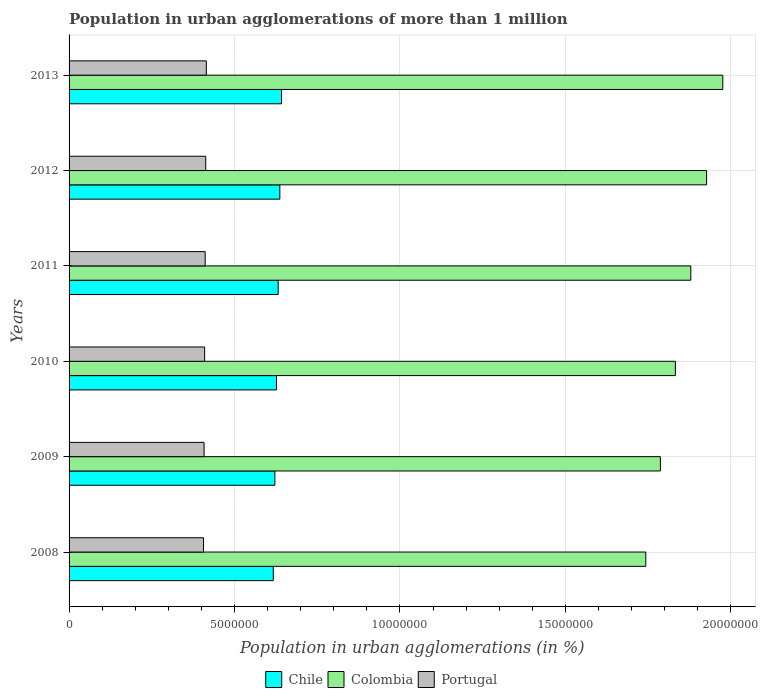How many different coloured bars are there?
Make the answer very short. 3. How many groups of bars are there?
Provide a short and direct response. 6. Are the number of bars on each tick of the Y-axis equal?
Give a very brief answer. Yes. What is the label of the 1st group of bars from the top?
Provide a succinct answer. 2013. In how many cases, is the number of bars for a given year not equal to the number of legend labels?
Make the answer very short. 0. What is the population in urban agglomerations in Colombia in 2012?
Ensure brevity in your answer.  1.93e+07. Across all years, what is the maximum population in urban agglomerations in Chile?
Your answer should be very brief. 6.42e+06. Across all years, what is the minimum population in urban agglomerations in Portugal?
Your answer should be very brief. 4.06e+06. What is the total population in urban agglomerations in Chile in the graph?
Your answer should be compact. 3.78e+07. What is the difference between the population in urban agglomerations in Colombia in 2010 and that in 2011?
Keep it short and to the point. -4.65e+05. What is the difference between the population in urban agglomerations in Colombia in 2010 and the population in urban agglomerations in Chile in 2012?
Your answer should be compact. 1.20e+07. What is the average population in urban agglomerations in Portugal per year?
Keep it short and to the point. 4.11e+06. In the year 2008, what is the difference between the population in urban agglomerations in Colombia and population in urban agglomerations in Portugal?
Your response must be concise. 1.34e+07. In how many years, is the population in urban agglomerations in Portugal greater than 19000000 %?
Provide a short and direct response. 0. What is the ratio of the population in urban agglomerations in Portugal in 2008 to that in 2009?
Make the answer very short. 1. Is the difference between the population in urban agglomerations in Colombia in 2010 and 2013 greater than the difference between the population in urban agglomerations in Portugal in 2010 and 2013?
Give a very brief answer. No. What is the difference between the highest and the second highest population in urban agglomerations in Colombia?
Your answer should be compact. 4.90e+05. What is the difference between the highest and the lowest population in urban agglomerations in Chile?
Offer a terse response. 2.50e+05. In how many years, is the population in urban agglomerations in Colombia greater than the average population in urban agglomerations in Colombia taken over all years?
Give a very brief answer. 3. What does the 3rd bar from the top in 2013 represents?
Provide a short and direct response. Chile. How many bars are there?
Offer a very short reply. 18. Does the graph contain any zero values?
Your answer should be compact. No. Does the graph contain grids?
Provide a short and direct response. Yes. Where does the legend appear in the graph?
Offer a terse response. Bottom center. How many legend labels are there?
Provide a short and direct response. 3. What is the title of the graph?
Provide a succinct answer. Population in urban agglomerations of more than 1 million. What is the label or title of the X-axis?
Offer a very short reply. Population in urban agglomerations (in %). What is the Population in urban agglomerations (in %) of Chile in 2008?
Offer a very short reply. 6.17e+06. What is the Population in urban agglomerations (in %) in Colombia in 2008?
Keep it short and to the point. 1.74e+07. What is the Population in urban agglomerations (in %) in Portugal in 2008?
Ensure brevity in your answer.  4.06e+06. What is the Population in urban agglomerations (in %) in Chile in 2009?
Provide a short and direct response. 6.22e+06. What is the Population in urban agglomerations (in %) of Colombia in 2009?
Ensure brevity in your answer.  1.79e+07. What is the Population in urban agglomerations (in %) of Portugal in 2009?
Ensure brevity in your answer.  4.08e+06. What is the Population in urban agglomerations (in %) in Chile in 2010?
Provide a short and direct response. 6.27e+06. What is the Population in urban agglomerations (in %) of Colombia in 2010?
Your response must be concise. 1.83e+07. What is the Population in urban agglomerations (in %) of Portugal in 2010?
Give a very brief answer. 4.10e+06. What is the Population in urban agglomerations (in %) of Chile in 2011?
Your answer should be compact. 6.32e+06. What is the Population in urban agglomerations (in %) in Colombia in 2011?
Your answer should be very brief. 1.88e+07. What is the Population in urban agglomerations (in %) of Portugal in 2011?
Provide a short and direct response. 4.11e+06. What is the Population in urban agglomerations (in %) of Chile in 2012?
Make the answer very short. 6.37e+06. What is the Population in urban agglomerations (in %) in Colombia in 2012?
Your answer should be very brief. 1.93e+07. What is the Population in urban agglomerations (in %) in Portugal in 2012?
Ensure brevity in your answer.  4.13e+06. What is the Population in urban agglomerations (in %) of Chile in 2013?
Your answer should be compact. 6.42e+06. What is the Population in urban agglomerations (in %) of Colombia in 2013?
Your answer should be very brief. 1.98e+07. What is the Population in urban agglomerations (in %) in Portugal in 2013?
Ensure brevity in your answer.  4.15e+06. Across all years, what is the maximum Population in urban agglomerations (in %) in Chile?
Your answer should be compact. 6.42e+06. Across all years, what is the maximum Population in urban agglomerations (in %) of Colombia?
Keep it short and to the point. 1.98e+07. Across all years, what is the maximum Population in urban agglomerations (in %) of Portugal?
Make the answer very short. 4.15e+06. Across all years, what is the minimum Population in urban agglomerations (in %) in Chile?
Provide a short and direct response. 6.17e+06. Across all years, what is the minimum Population in urban agglomerations (in %) in Colombia?
Your response must be concise. 1.74e+07. Across all years, what is the minimum Population in urban agglomerations (in %) in Portugal?
Make the answer very short. 4.06e+06. What is the total Population in urban agglomerations (in %) in Chile in the graph?
Keep it short and to the point. 3.78e+07. What is the total Population in urban agglomerations (in %) in Colombia in the graph?
Give a very brief answer. 1.11e+08. What is the total Population in urban agglomerations (in %) in Portugal in the graph?
Your answer should be very brief. 2.46e+07. What is the difference between the Population in urban agglomerations (in %) of Chile in 2008 and that in 2009?
Your answer should be compact. -4.91e+04. What is the difference between the Population in urban agglomerations (in %) in Colombia in 2008 and that in 2009?
Provide a short and direct response. -4.41e+05. What is the difference between the Population in urban agglomerations (in %) of Portugal in 2008 and that in 2009?
Provide a short and direct response. -1.67e+04. What is the difference between the Population in urban agglomerations (in %) of Chile in 2008 and that in 2010?
Offer a terse response. -9.87e+04. What is the difference between the Population in urban agglomerations (in %) in Colombia in 2008 and that in 2010?
Make the answer very short. -8.95e+05. What is the difference between the Population in urban agglomerations (in %) of Portugal in 2008 and that in 2010?
Offer a terse response. -3.35e+04. What is the difference between the Population in urban agglomerations (in %) of Chile in 2008 and that in 2011?
Give a very brief answer. -1.49e+05. What is the difference between the Population in urban agglomerations (in %) in Colombia in 2008 and that in 2011?
Keep it short and to the point. -1.36e+06. What is the difference between the Population in urban agglomerations (in %) of Portugal in 2008 and that in 2011?
Give a very brief answer. -5.04e+04. What is the difference between the Population in urban agglomerations (in %) in Chile in 2008 and that in 2012?
Give a very brief answer. -1.99e+05. What is the difference between the Population in urban agglomerations (in %) in Colombia in 2008 and that in 2012?
Keep it short and to the point. -1.84e+06. What is the difference between the Population in urban agglomerations (in %) of Portugal in 2008 and that in 2012?
Your answer should be very brief. -6.74e+04. What is the difference between the Population in urban agglomerations (in %) of Chile in 2008 and that in 2013?
Offer a terse response. -2.50e+05. What is the difference between the Population in urban agglomerations (in %) in Colombia in 2008 and that in 2013?
Offer a terse response. -2.33e+06. What is the difference between the Population in urban agglomerations (in %) in Portugal in 2008 and that in 2013?
Give a very brief answer. -8.44e+04. What is the difference between the Population in urban agglomerations (in %) of Chile in 2009 and that in 2010?
Provide a short and direct response. -4.96e+04. What is the difference between the Population in urban agglomerations (in %) in Colombia in 2009 and that in 2010?
Ensure brevity in your answer.  -4.53e+05. What is the difference between the Population in urban agglomerations (in %) of Portugal in 2009 and that in 2010?
Offer a terse response. -1.68e+04. What is the difference between the Population in urban agglomerations (in %) in Chile in 2009 and that in 2011?
Your answer should be compact. -9.95e+04. What is the difference between the Population in urban agglomerations (in %) in Colombia in 2009 and that in 2011?
Your answer should be very brief. -9.19e+05. What is the difference between the Population in urban agglomerations (in %) in Portugal in 2009 and that in 2011?
Make the answer very short. -3.37e+04. What is the difference between the Population in urban agglomerations (in %) in Chile in 2009 and that in 2012?
Your answer should be very brief. -1.50e+05. What is the difference between the Population in urban agglomerations (in %) in Colombia in 2009 and that in 2012?
Give a very brief answer. -1.40e+06. What is the difference between the Population in urban agglomerations (in %) of Portugal in 2009 and that in 2012?
Offer a very short reply. -5.07e+04. What is the difference between the Population in urban agglomerations (in %) of Chile in 2009 and that in 2013?
Your response must be concise. -2.01e+05. What is the difference between the Population in urban agglomerations (in %) of Colombia in 2009 and that in 2013?
Ensure brevity in your answer.  -1.89e+06. What is the difference between the Population in urban agglomerations (in %) in Portugal in 2009 and that in 2013?
Offer a very short reply. -6.77e+04. What is the difference between the Population in urban agglomerations (in %) in Chile in 2010 and that in 2011?
Your response must be concise. -5.00e+04. What is the difference between the Population in urban agglomerations (in %) in Colombia in 2010 and that in 2011?
Ensure brevity in your answer.  -4.65e+05. What is the difference between the Population in urban agglomerations (in %) in Portugal in 2010 and that in 2011?
Provide a succinct answer. -1.69e+04. What is the difference between the Population in urban agglomerations (in %) of Chile in 2010 and that in 2012?
Your answer should be very brief. -1.00e+05. What is the difference between the Population in urban agglomerations (in %) of Colombia in 2010 and that in 2012?
Offer a terse response. -9.43e+05. What is the difference between the Population in urban agglomerations (in %) of Portugal in 2010 and that in 2012?
Keep it short and to the point. -3.39e+04. What is the difference between the Population in urban agglomerations (in %) in Chile in 2010 and that in 2013?
Keep it short and to the point. -1.51e+05. What is the difference between the Population in urban agglomerations (in %) of Colombia in 2010 and that in 2013?
Give a very brief answer. -1.43e+06. What is the difference between the Population in urban agglomerations (in %) in Portugal in 2010 and that in 2013?
Provide a short and direct response. -5.09e+04. What is the difference between the Population in urban agglomerations (in %) of Chile in 2011 and that in 2012?
Your answer should be compact. -5.04e+04. What is the difference between the Population in urban agglomerations (in %) in Colombia in 2011 and that in 2012?
Provide a short and direct response. -4.77e+05. What is the difference between the Population in urban agglomerations (in %) of Portugal in 2011 and that in 2012?
Provide a short and direct response. -1.70e+04. What is the difference between the Population in urban agglomerations (in %) of Chile in 2011 and that in 2013?
Offer a very short reply. -1.01e+05. What is the difference between the Population in urban agglomerations (in %) of Colombia in 2011 and that in 2013?
Give a very brief answer. -9.67e+05. What is the difference between the Population in urban agglomerations (in %) of Portugal in 2011 and that in 2013?
Give a very brief answer. -3.40e+04. What is the difference between the Population in urban agglomerations (in %) of Chile in 2012 and that in 2013?
Make the answer very short. -5.08e+04. What is the difference between the Population in urban agglomerations (in %) of Colombia in 2012 and that in 2013?
Make the answer very short. -4.90e+05. What is the difference between the Population in urban agglomerations (in %) of Portugal in 2012 and that in 2013?
Provide a short and direct response. -1.70e+04. What is the difference between the Population in urban agglomerations (in %) of Chile in 2008 and the Population in urban agglomerations (in %) of Colombia in 2009?
Ensure brevity in your answer.  -1.17e+07. What is the difference between the Population in urban agglomerations (in %) of Chile in 2008 and the Population in urban agglomerations (in %) of Portugal in 2009?
Your response must be concise. 2.09e+06. What is the difference between the Population in urban agglomerations (in %) in Colombia in 2008 and the Population in urban agglomerations (in %) in Portugal in 2009?
Your response must be concise. 1.33e+07. What is the difference between the Population in urban agglomerations (in %) of Chile in 2008 and the Population in urban agglomerations (in %) of Colombia in 2010?
Provide a succinct answer. -1.22e+07. What is the difference between the Population in urban agglomerations (in %) in Chile in 2008 and the Population in urban agglomerations (in %) in Portugal in 2010?
Your response must be concise. 2.07e+06. What is the difference between the Population in urban agglomerations (in %) of Colombia in 2008 and the Population in urban agglomerations (in %) of Portugal in 2010?
Make the answer very short. 1.33e+07. What is the difference between the Population in urban agglomerations (in %) of Chile in 2008 and the Population in urban agglomerations (in %) of Colombia in 2011?
Make the answer very short. -1.26e+07. What is the difference between the Population in urban agglomerations (in %) of Chile in 2008 and the Population in urban agglomerations (in %) of Portugal in 2011?
Give a very brief answer. 2.06e+06. What is the difference between the Population in urban agglomerations (in %) in Colombia in 2008 and the Population in urban agglomerations (in %) in Portugal in 2011?
Offer a very short reply. 1.33e+07. What is the difference between the Population in urban agglomerations (in %) of Chile in 2008 and the Population in urban agglomerations (in %) of Colombia in 2012?
Keep it short and to the point. -1.31e+07. What is the difference between the Population in urban agglomerations (in %) of Chile in 2008 and the Population in urban agglomerations (in %) of Portugal in 2012?
Offer a terse response. 2.04e+06. What is the difference between the Population in urban agglomerations (in %) of Colombia in 2008 and the Population in urban agglomerations (in %) of Portugal in 2012?
Offer a very short reply. 1.33e+07. What is the difference between the Population in urban agglomerations (in %) of Chile in 2008 and the Population in urban agglomerations (in %) of Colombia in 2013?
Your answer should be very brief. -1.36e+07. What is the difference between the Population in urban agglomerations (in %) of Chile in 2008 and the Population in urban agglomerations (in %) of Portugal in 2013?
Your answer should be very brief. 2.02e+06. What is the difference between the Population in urban agglomerations (in %) of Colombia in 2008 and the Population in urban agglomerations (in %) of Portugal in 2013?
Keep it short and to the point. 1.33e+07. What is the difference between the Population in urban agglomerations (in %) of Chile in 2009 and the Population in urban agglomerations (in %) of Colombia in 2010?
Provide a succinct answer. -1.21e+07. What is the difference between the Population in urban agglomerations (in %) of Chile in 2009 and the Population in urban agglomerations (in %) of Portugal in 2010?
Keep it short and to the point. 2.12e+06. What is the difference between the Population in urban agglomerations (in %) of Colombia in 2009 and the Population in urban agglomerations (in %) of Portugal in 2010?
Offer a terse response. 1.38e+07. What is the difference between the Population in urban agglomerations (in %) in Chile in 2009 and the Population in urban agglomerations (in %) in Colombia in 2011?
Provide a succinct answer. -1.26e+07. What is the difference between the Population in urban agglomerations (in %) of Chile in 2009 and the Population in urban agglomerations (in %) of Portugal in 2011?
Your response must be concise. 2.11e+06. What is the difference between the Population in urban agglomerations (in %) of Colombia in 2009 and the Population in urban agglomerations (in %) of Portugal in 2011?
Provide a short and direct response. 1.38e+07. What is the difference between the Population in urban agglomerations (in %) of Chile in 2009 and the Population in urban agglomerations (in %) of Colombia in 2012?
Offer a very short reply. -1.30e+07. What is the difference between the Population in urban agglomerations (in %) of Chile in 2009 and the Population in urban agglomerations (in %) of Portugal in 2012?
Offer a terse response. 2.09e+06. What is the difference between the Population in urban agglomerations (in %) of Colombia in 2009 and the Population in urban agglomerations (in %) of Portugal in 2012?
Your response must be concise. 1.37e+07. What is the difference between the Population in urban agglomerations (in %) of Chile in 2009 and the Population in urban agglomerations (in %) of Colombia in 2013?
Provide a succinct answer. -1.35e+07. What is the difference between the Population in urban agglomerations (in %) in Chile in 2009 and the Population in urban agglomerations (in %) in Portugal in 2013?
Provide a succinct answer. 2.07e+06. What is the difference between the Population in urban agglomerations (in %) in Colombia in 2009 and the Population in urban agglomerations (in %) in Portugal in 2013?
Your answer should be very brief. 1.37e+07. What is the difference between the Population in urban agglomerations (in %) in Chile in 2010 and the Population in urban agglomerations (in %) in Colombia in 2011?
Keep it short and to the point. -1.25e+07. What is the difference between the Population in urban agglomerations (in %) in Chile in 2010 and the Population in urban agglomerations (in %) in Portugal in 2011?
Your answer should be compact. 2.16e+06. What is the difference between the Population in urban agglomerations (in %) of Colombia in 2010 and the Population in urban agglomerations (in %) of Portugal in 2011?
Offer a terse response. 1.42e+07. What is the difference between the Population in urban agglomerations (in %) of Chile in 2010 and the Population in urban agglomerations (in %) of Colombia in 2012?
Your answer should be compact. -1.30e+07. What is the difference between the Population in urban agglomerations (in %) in Chile in 2010 and the Population in urban agglomerations (in %) in Portugal in 2012?
Provide a short and direct response. 2.14e+06. What is the difference between the Population in urban agglomerations (in %) in Colombia in 2010 and the Population in urban agglomerations (in %) in Portugal in 2012?
Give a very brief answer. 1.42e+07. What is the difference between the Population in urban agglomerations (in %) of Chile in 2010 and the Population in urban agglomerations (in %) of Colombia in 2013?
Your answer should be compact. -1.35e+07. What is the difference between the Population in urban agglomerations (in %) of Chile in 2010 and the Population in urban agglomerations (in %) of Portugal in 2013?
Provide a succinct answer. 2.12e+06. What is the difference between the Population in urban agglomerations (in %) in Colombia in 2010 and the Population in urban agglomerations (in %) in Portugal in 2013?
Ensure brevity in your answer.  1.42e+07. What is the difference between the Population in urban agglomerations (in %) of Chile in 2011 and the Population in urban agglomerations (in %) of Colombia in 2012?
Provide a short and direct response. -1.29e+07. What is the difference between the Population in urban agglomerations (in %) of Chile in 2011 and the Population in urban agglomerations (in %) of Portugal in 2012?
Ensure brevity in your answer.  2.19e+06. What is the difference between the Population in urban agglomerations (in %) in Colombia in 2011 and the Population in urban agglomerations (in %) in Portugal in 2012?
Ensure brevity in your answer.  1.47e+07. What is the difference between the Population in urban agglomerations (in %) in Chile in 2011 and the Population in urban agglomerations (in %) in Colombia in 2013?
Make the answer very short. -1.34e+07. What is the difference between the Population in urban agglomerations (in %) of Chile in 2011 and the Population in urban agglomerations (in %) of Portugal in 2013?
Offer a terse response. 2.17e+06. What is the difference between the Population in urban agglomerations (in %) of Colombia in 2011 and the Population in urban agglomerations (in %) of Portugal in 2013?
Ensure brevity in your answer.  1.46e+07. What is the difference between the Population in urban agglomerations (in %) in Chile in 2012 and the Population in urban agglomerations (in %) in Colombia in 2013?
Your answer should be compact. -1.34e+07. What is the difference between the Population in urban agglomerations (in %) of Chile in 2012 and the Population in urban agglomerations (in %) of Portugal in 2013?
Provide a short and direct response. 2.22e+06. What is the difference between the Population in urban agglomerations (in %) of Colombia in 2012 and the Population in urban agglomerations (in %) of Portugal in 2013?
Offer a terse response. 1.51e+07. What is the average Population in urban agglomerations (in %) of Chile per year?
Your answer should be very brief. 6.29e+06. What is the average Population in urban agglomerations (in %) in Colombia per year?
Offer a very short reply. 1.86e+07. What is the average Population in urban agglomerations (in %) of Portugal per year?
Your answer should be very brief. 4.11e+06. In the year 2008, what is the difference between the Population in urban agglomerations (in %) of Chile and Population in urban agglomerations (in %) of Colombia?
Your response must be concise. -1.13e+07. In the year 2008, what is the difference between the Population in urban agglomerations (in %) in Chile and Population in urban agglomerations (in %) in Portugal?
Ensure brevity in your answer.  2.11e+06. In the year 2008, what is the difference between the Population in urban agglomerations (in %) in Colombia and Population in urban agglomerations (in %) in Portugal?
Ensure brevity in your answer.  1.34e+07. In the year 2009, what is the difference between the Population in urban agglomerations (in %) in Chile and Population in urban agglomerations (in %) in Colombia?
Keep it short and to the point. -1.17e+07. In the year 2009, what is the difference between the Population in urban agglomerations (in %) in Chile and Population in urban agglomerations (in %) in Portugal?
Ensure brevity in your answer.  2.14e+06. In the year 2009, what is the difference between the Population in urban agglomerations (in %) of Colombia and Population in urban agglomerations (in %) of Portugal?
Your answer should be compact. 1.38e+07. In the year 2010, what is the difference between the Population in urban agglomerations (in %) of Chile and Population in urban agglomerations (in %) of Colombia?
Give a very brief answer. -1.21e+07. In the year 2010, what is the difference between the Population in urban agglomerations (in %) in Chile and Population in urban agglomerations (in %) in Portugal?
Your answer should be very brief. 2.17e+06. In the year 2010, what is the difference between the Population in urban agglomerations (in %) in Colombia and Population in urban agglomerations (in %) in Portugal?
Make the answer very short. 1.42e+07. In the year 2011, what is the difference between the Population in urban agglomerations (in %) in Chile and Population in urban agglomerations (in %) in Colombia?
Keep it short and to the point. -1.25e+07. In the year 2011, what is the difference between the Population in urban agglomerations (in %) of Chile and Population in urban agglomerations (in %) of Portugal?
Give a very brief answer. 2.21e+06. In the year 2011, what is the difference between the Population in urban agglomerations (in %) of Colombia and Population in urban agglomerations (in %) of Portugal?
Make the answer very short. 1.47e+07. In the year 2012, what is the difference between the Population in urban agglomerations (in %) of Chile and Population in urban agglomerations (in %) of Colombia?
Provide a short and direct response. -1.29e+07. In the year 2012, what is the difference between the Population in urban agglomerations (in %) of Chile and Population in urban agglomerations (in %) of Portugal?
Give a very brief answer. 2.24e+06. In the year 2012, what is the difference between the Population in urban agglomerations (in %) in Colombia and Population in urban agglomerations (in %) in Portugal?
Provide a short and direct response. 1.51e+07. In the year 2013, what is the difference between the Population in urban agglomerations (in %) in Chile and Population in urban agglomerations (in %) in Colombia?
Make the answer very short. -1.33e+07. In the year 2013, what is the difference between the Population in urban agglomerations (in %) of Chile and Population in urban agglomerations (in %) of Portugal?
Provide a succinct answer. 2.27e+06. In the year 2013, what is the difference between the Population in urban agglomerations (in %) in Colombia and Population in urban agglomerations (in %) in Portugal?
Provide a short and direct response. 1.56e+07. What is the ratio of the Population in urban agglomerations (in %) of Chile in 2008 to that in 2009?
Provide a succinct answer. 0.99. What is the ratio of the Population in urban agglomerations (in %) of Colombia in 2008 to that in 2009?
Your answer should be very brief. 0.98. What is the ratio of the Population in urban agglomerations (in %) in Chile in 2008 to that in 2010?
Provide a short and direct response. 0.98. What is the ratio of the Population in urban agglomerations (in %) in Colombia in 2008 to that in 2010?
Your answer should be compact. 0.95. What is the ratio of the Population in urban agglomerations (in %) of Chile in 2008 to that in 2011?
Your answer should be compact. 0.98. What is the ratio of the Population in urban agglomerations (in %) of Colombia in 2008 to that in 2011?
Keep it short and to the point. 0.93. What is the ratio of the Population in urban agglomerations (in %) in Chile in 2008 to that in 2012?
Your response must be concise. 0.97. What is the ratio of the Population in urban agglomerations (in %) of Colombia in 2008 to that in 2012?
Give a very brief answer. 0.9. What is the ratio of the Population in urban agglomerations (in %) in Portugal in 2008 to that in 2012?
Your answer should be very brief. 0.98. What is the ratio of the Population in urban agglomerations (in %) of Chile in 2008 to that in 2013?
Make the answer very short. 0.96. What is the ratio of the Population in urban agglomerations (in %) in Colombia in 2008 to that in 2013?
Offer a very short reply. 0.88. What is the ratio of the Population in urban agglomerations (in %) in Portugal in 2008 to that in 2013?
Your response must be concise. 0.98. What is the ratio of the Population in urban agglomerations (in %) in Colombia in 2009 to that in 2010?
Offer a very short reply. 0.98. What is the ratio of the Population in urban agglomerations (in %) in Chile in 2009 to that in 2011?
Offer a very short reply. 0.98. What is the ratio of the Population in urban agglomerations (in %) of Colombia in 2009 to that in 2011?
Ensure brevity in your answer.  0.95. What is the ratio of the Population in urban agglomerations (in %) in Chile in 2009 to that in 2012?
Your answer should be compact. 0.98. What is the ratio of the Population in urban agglomerations (in %) in Colombia in 2009 to that in 2012?
Offer a terse response. 0.93. What is the ratio of the Population in urban agglomerations (in %) of Portugal in 2009 to that in 2012?
Provide a short and direct response. 0.99. What is the ratio of the Population in urban agglomerations (in %) of Chile in 2009 to that in 2013?
Offer a terse response. 0.97. What is the ratio of the Population in urban agglomerations (in %) in Colombia in 2009 to that in 2013?
Your response must be concise. 0.9. What is the ratio of the Population in urban agglomerations (in %) of Portugal in 2009 to that in 2013?
Offer a terse response. 0.98. What is the ratio of the Population in urban agglomerations (in %) in Chile in 2010 to that in 2011?
Offer a very short reply. 0.99. What is the ratio of the Population in urban agglomerations (in %) in Colombia in 2010 to that in 2011?
Your response must be concise. 0.98. What is the ratio of the Population in urban agglomerations (in %) of Portugal in 2010 to that in 2011?
Your response must be concise. 1. What is the ratio of the Population in urban agglomerations (in %) of Chile in 2010 to that in 2012?
Ensure brevity in your answer.  0.98. What is the ratio of the Population in urban agglomerations (in %) of Colombia in 2010 to that in 2012?
Provide a short and direct response. 0.95. What is the ratio of the Population in urban agglomerations (in %) of Chile in 2010 to that in 2013?
Give a very brief answer. 0.98. What is the ratio of the Population in urban agglomerations (in %) in Colombia in 2010 to that in 2013?
Keep it short and to the point. 0.93. What is the ratio of the Population in urban agglomerations (in %) in Colombia in 2011 to that in 2012?
Make the answer very short. 0.98. What is the ratio of the Population in urban agglomerations (in %) of Chile in 2011 to that in 2013?
Offer a very short reply. 0.98. What is the ratio of the Population in urban agglomerations (in %) in Colombia in 2011 to that in 2013?
Provide a short and direct response. 0.95. What is the ratio of the Population in urban agglomerations (in %) in Chile in 2012 to that in 2013?
Ensure brevity in your answer.  0.99. What is the ratio of the Population in urban agglomerations (in %) of Colombia in 2012 to that in 2013?
Keep it short and to the point. 0.98. What is the ratio of the Population in urban agglomerations (in %) in Portugal in 2012 to that in 2013?
Provide a succinct answer. 1. What is the difference between the highest and the second highest Population in urban agglomerations (in %) of Chile?
Your response must be concise. 5.08e+04. What is the difference between the highest and the second highest Population in urban agglomerations (in %) in Colombia?
Give a very brief answer. 4.90e+05. What is the difference between the highest and the second highest Population in urban agglomerations (in %) in Portugal?
Provide a succinct answer. 1.70e+04. What is the difference between the highest and the lowest Population in urban agglomerations (in %) of Chile?
Keep it short and to the point. 2.50e+05. What is the difference between the highest and the lowest Population in urban agglomerations (in %) of Colombia?
Keep it short and to the point. 2.33e+06. What is the difference between the highest and the lowest Population in urban agglomerations (in %) in Portugal?
Offer a terse response. 8.44e+04. 